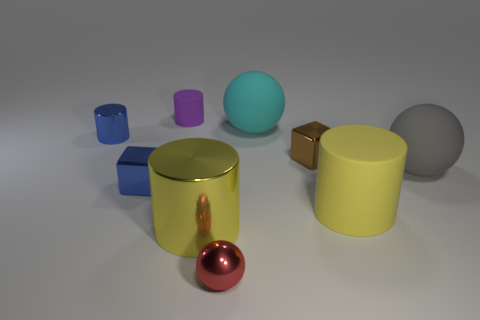Subtract all balls. How many objects are left? 6 Add 6 small red shiny objects. How many small red shiny objects are left? 7 Add 7 small balls. How many small balls exist? 8 Subtract 0 green cylinders. How many objects are left? 9 Subtract all cylinders. Subtract all blue cylinders. How many objects are left? 4 